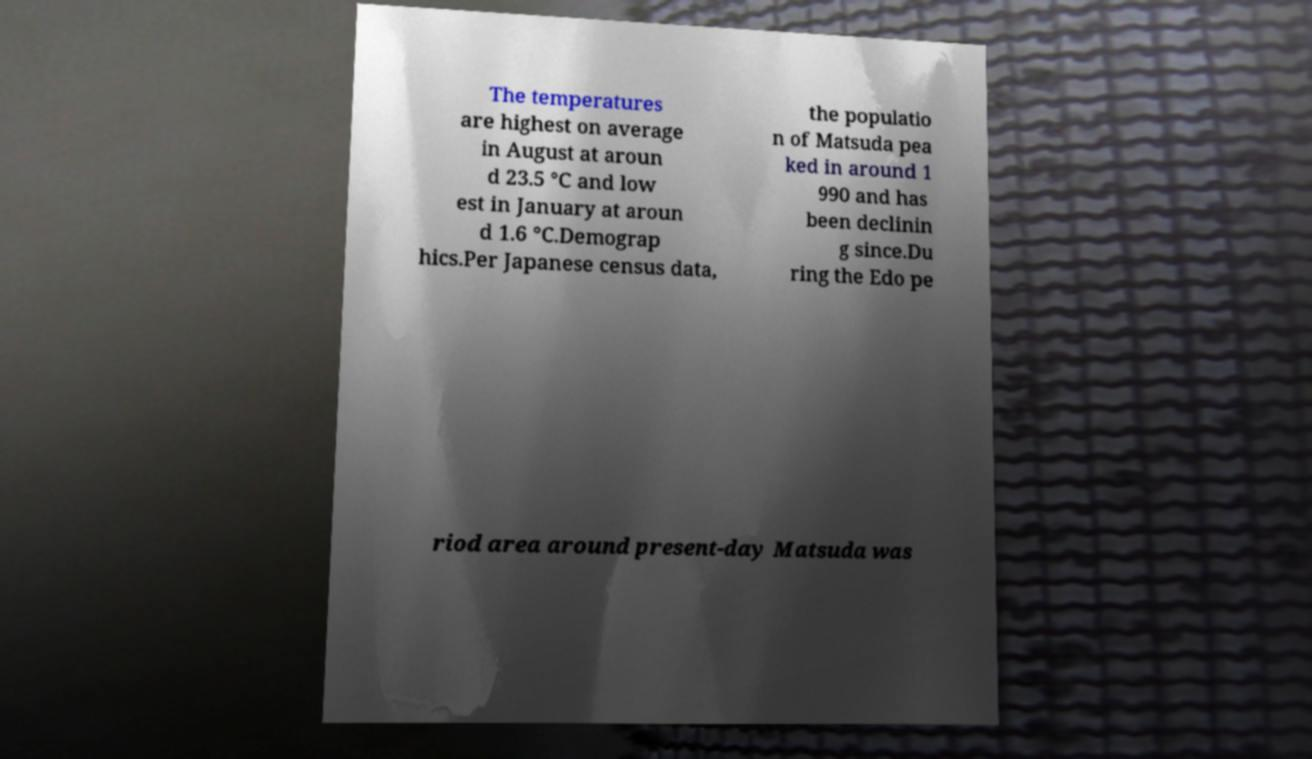What messages or text are displayed in this image? I need them in a readable, typed format. The temperatures are highest on average in August at aroun d 23.5 °C and low est in January at aroun d 1.6 °C.Demograp hics.Per Japanese census data, the populatio n of Matsuda pea ked in around 1 990 and has been declinin g since.Du ring the Edo pe riod area around present-day Matsuda was 